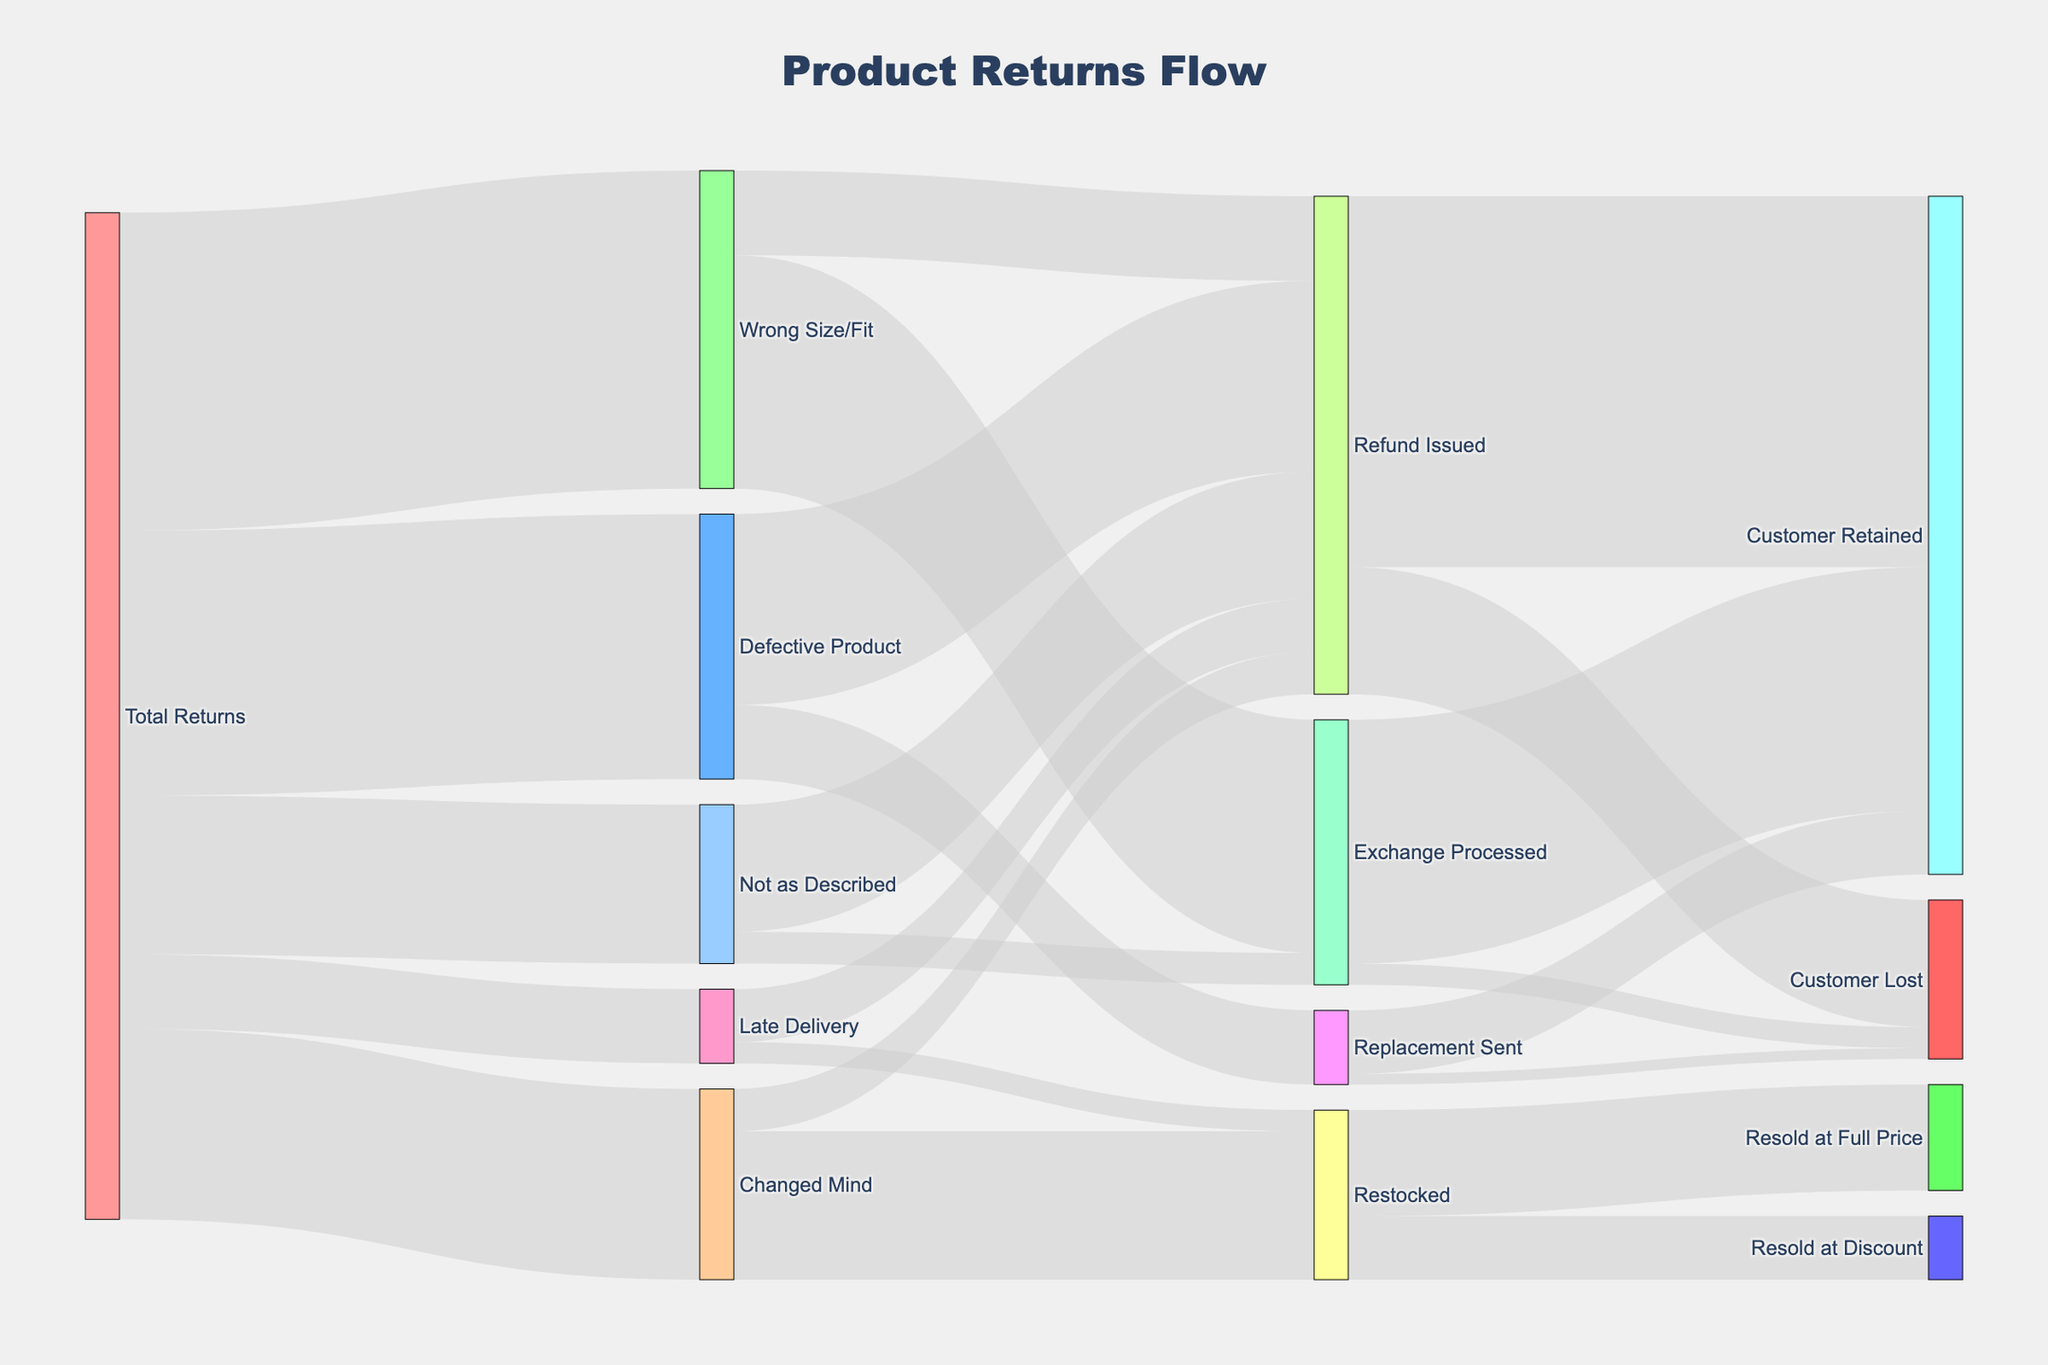What is the title of the Sankey Diagram? The title of the diagram is displayed at the top of the image and provides a summary of what the diagram is showcasing.
Answer: Product Returns Flow What is the most common reason for returns? By looking at the flows coming out from "Total Returns" to various reasons, we can see that "Wrong Size/Fit" has the highest value.
Answer: Wrong Size/Fit How many total returns end up with a refund issued? Sum all flows that end at "Refund Issued" from different reasons including "Defective Product", "Wrong Size/Fit", "Changed Mind", "Late Delivery", and "Not as Described". Calculate: 1800 + 800 + 400 + 500 + 1200 = 4700
Answer: 4700 Which outcome has more occurrences, "Customer Retained" or "Customer Lost"? Look at the flows ending at "Customer Retained" and "Customer Lost". Sum the values: "Customer Retained" 3500 (Refund Issued) + 2300 (Exchange Processed) + 600 (Replacement Sent) = 6400, "Customer Lost" 1200 (Refund Issued) + 200 (Exchange Processed) + 100 (Replacement Sent) = 1500. Compare the sums.
Answer: Customer Retained What is the least common outcome? By inspecting all the nodes on the right-most side of the diagram, the node with the smallest value is identified. "Replacement Sent" having "Customer Lost" with 100 is the smallest.
Answer: Customer Lost from Replacement Sent How many "Changed Mind" returns are restocked? Directly follow the flow from "Changed Mind" to "Restocked".
Answer: 1400 Which reason for return has the highest proportion of its cases resulting in "Exchange Processed"? Analyze the proportion of each reason leading to "Exchange Processed". Only "Wrong Size/Fit" and "Not as Described" lead to exchanges. Calculate proportion: Wrong Size/Fit: 2200/3000 = 73.3%, Not as Described: 300/1500 = 20%.
Answer: Wrong Size/Fit How many total returns were restocked? Sum the flows ending at "Restocked" from "Changed Mind" and "Late Delivery". Calculate: 1400 + 200 = 1600
Answer: 1600 Is "Resold at Full Price" or "Resold at Discount" more frequent? Inspect the flows from "Restocked" ending at "Resold at Full Price" and "Resold at Discount". The values are 1000 for full price and 600 for discount.
Answer: Resold at Full Price How many returns are due to "Late Delivery"? Directly follow the flow from "Total Returns" to "Late Delivery".
Answer: 700 